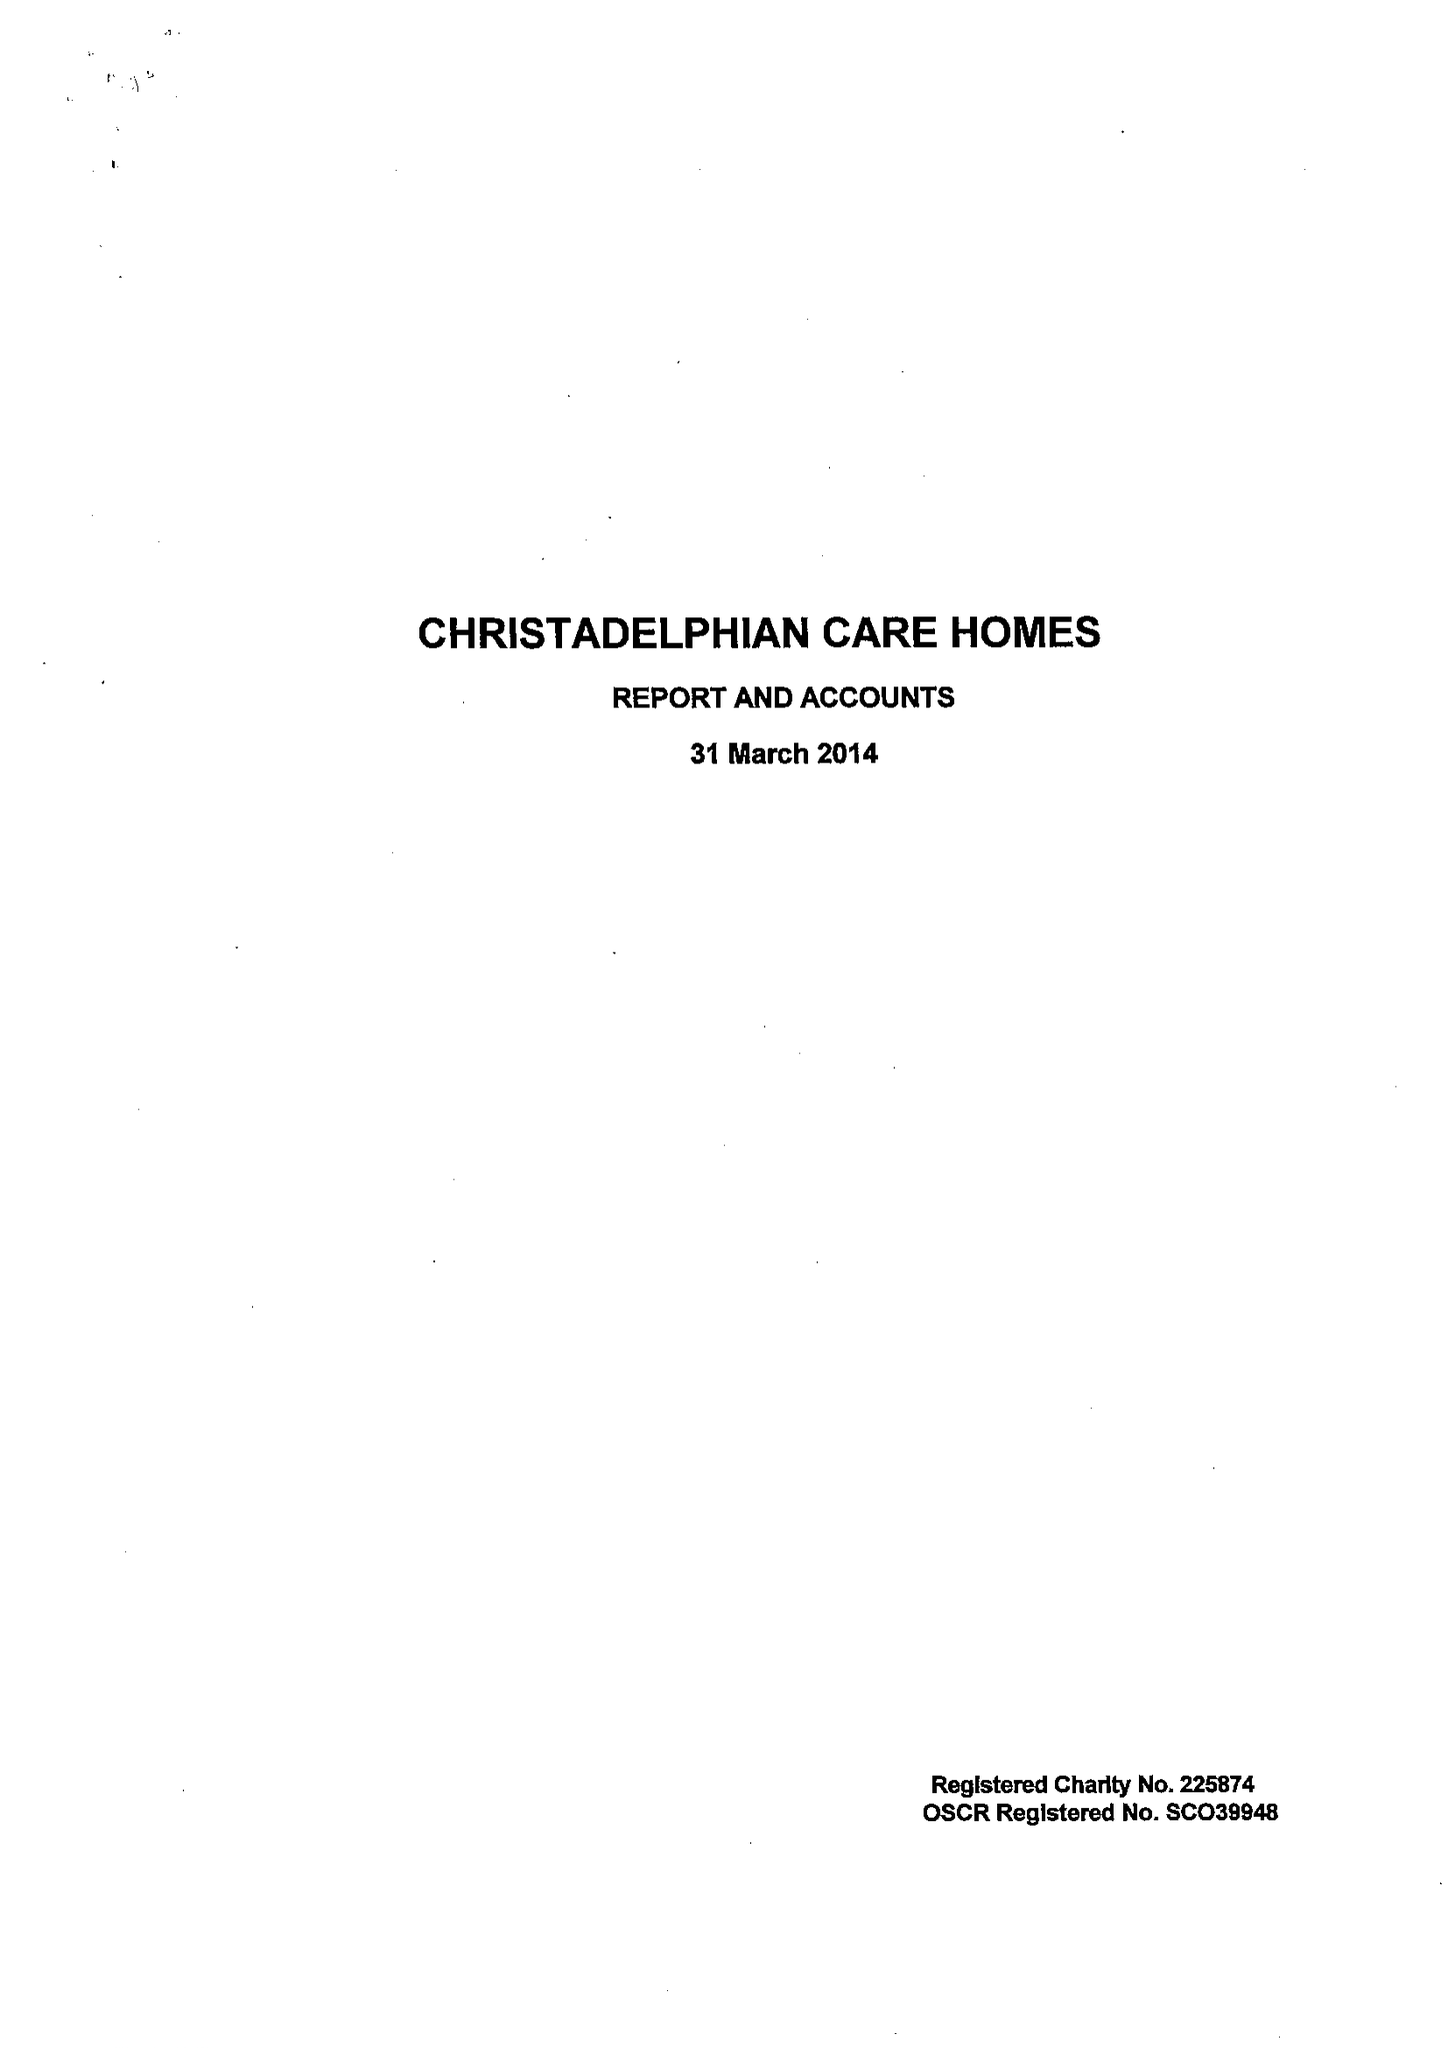What is the value for the income_annually_in_british_pounds?
Answer the question using a single word or phrase. 9205297.00 